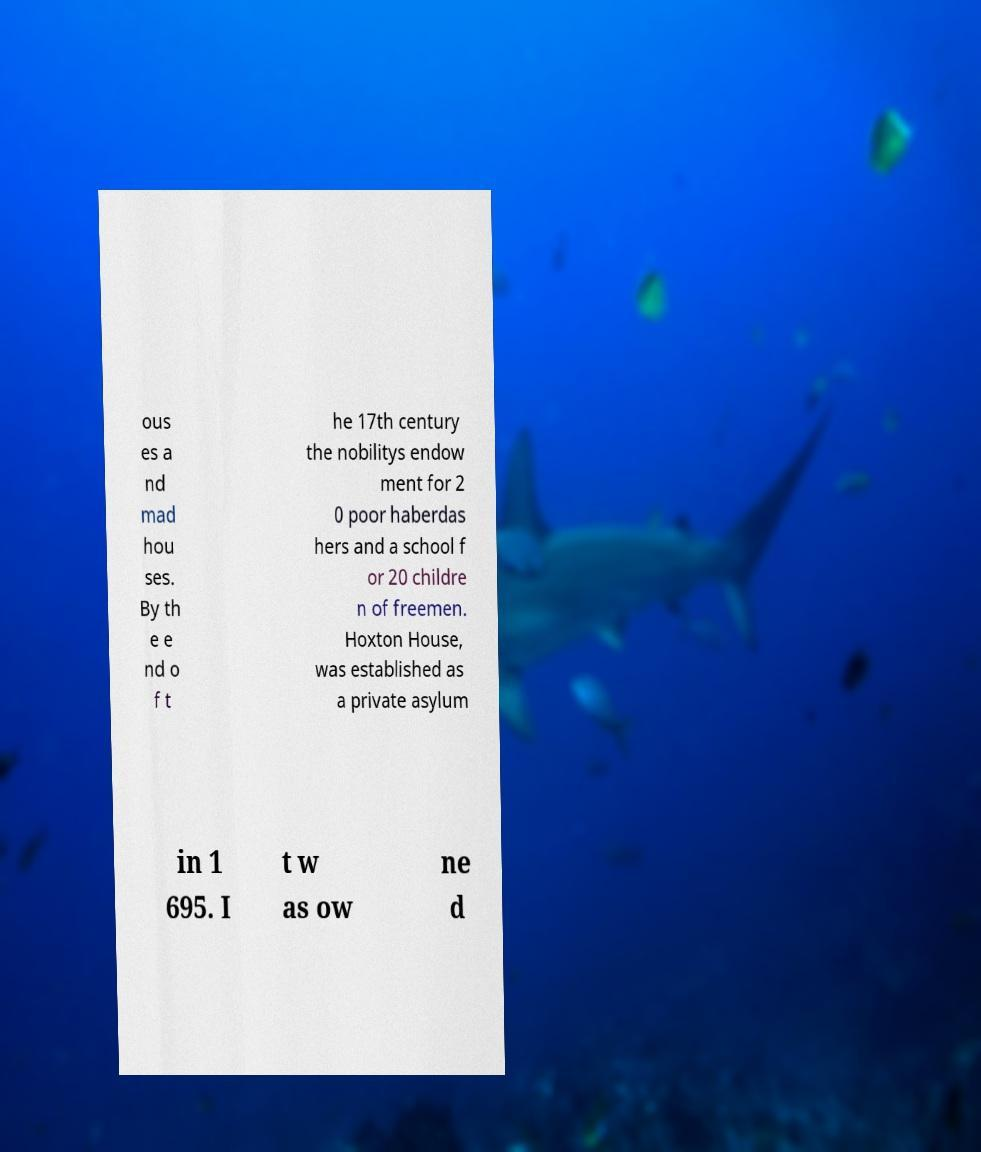Could you assist in decoding the text presented in this image and type it out clearly? ous es a nd mad hou ses. By th e e nd o f t he 17th century the nobilitys endow ment for 2 0 poor haberdas hers and a school f or 20 childre n of freemen. Hoxton House, was established as a private asylum in 1 695. I t w as ow ne d 